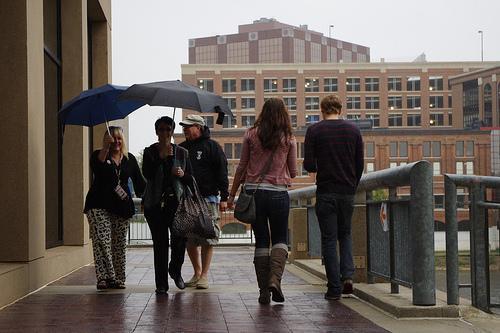How many people have umbrellas?
Give a very brief answer. 2. 